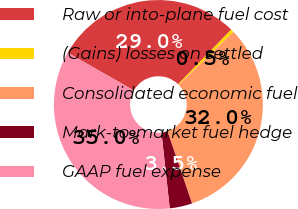Convert chart. <chart><loc_0><loc_0><loc_500><loc_500><pie_chart><fcel>Raw or into-plane fuel cost<fcel>(Gains) losses on settled<fcel>Consolidated economic fuel<fcel>Mark-to-market fuel hedge<fcel>GAAP fuel expense<nl><fcel>29.03%<fcel>0.5%<fcel>32.01%<fcel>3.48%<fcel>34.99%<nl></chart> 